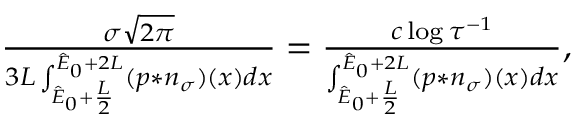<formula> <loc_0><loc_0><loc_500><loc_500>\begin{array} { r } { \frac { \sigma \sqrt { 2 \pi } } { 3 L \int _ { \hat { E } _ { 0 } + \frac { L } { 2 } } ^ { \hat { E } _ { 0 } + 2 L } ( p \ast n _ { \sigma } ) ( x ) d x } = \frac { c \log { \tau ^ { - 1 } } } { \int _ { \hat { E } _ { 0 } + \frac { L } { 2 } } ^ { \hat { E } _ { 0 } + 2 L } ( p \ast n _ { \sigma } ) ( x ) d x } , } \end{array}</formula> 